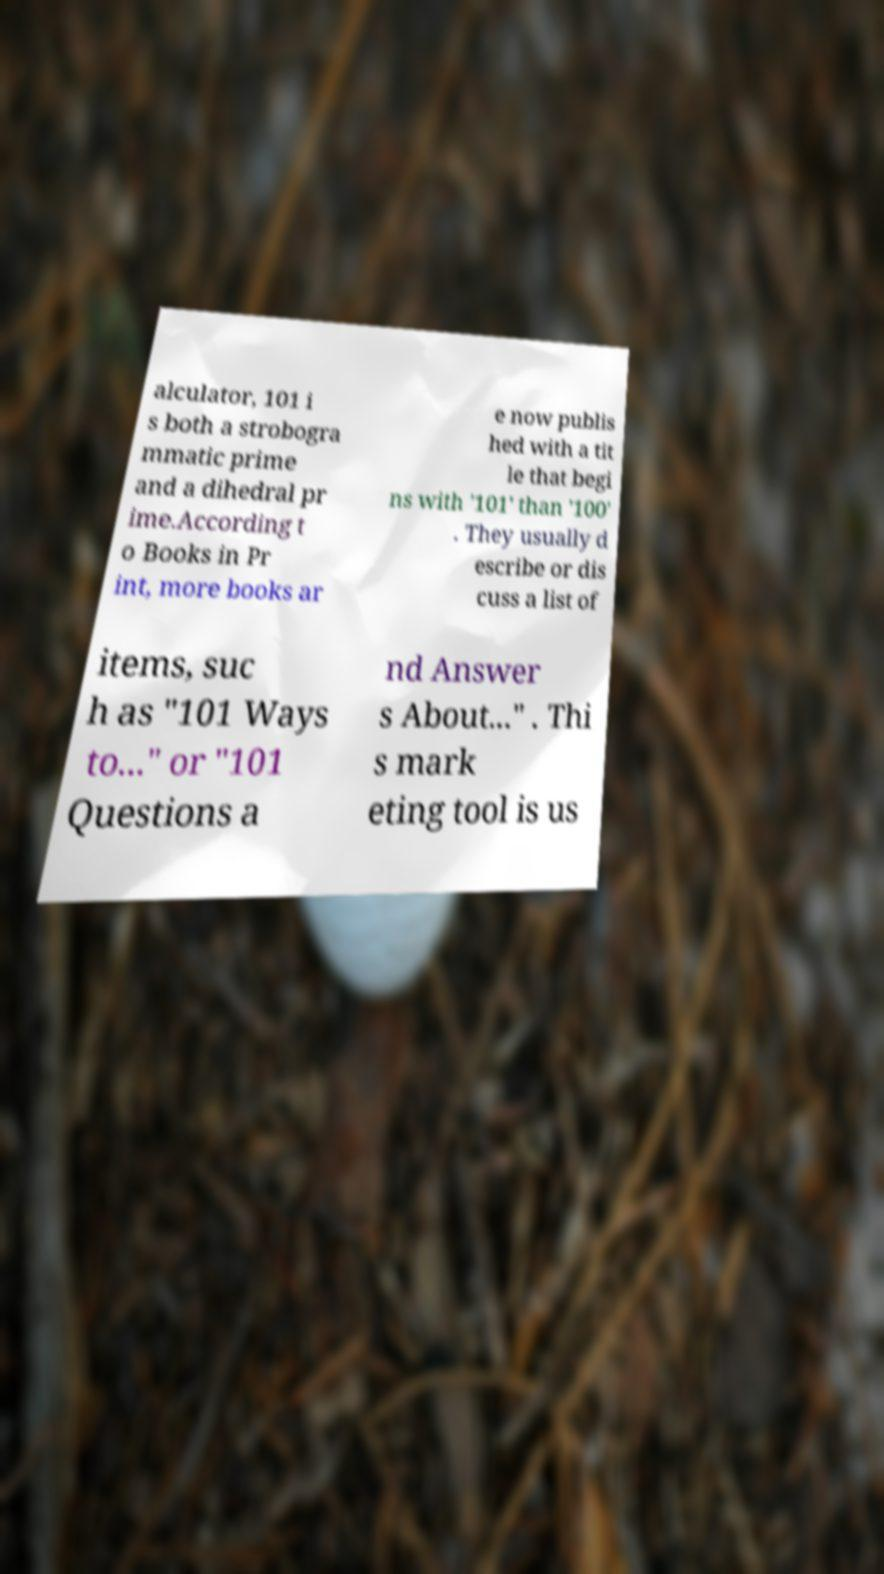There's text embedded in this image that I need extracted. Can you transcribe it verbatim? alculator, 101 i s both a strobogra mmatic prime and a dihedral pr ime.According t o Books in Pr int, more books ar e now publis hed with a tit le that begi ns with '101' than '100' . They usually d escribe or dis cuss a list of items, suc h as "101 Ways to..." or "101 Questions a nd Answer s About..." . Thi s mark eting tool is us 